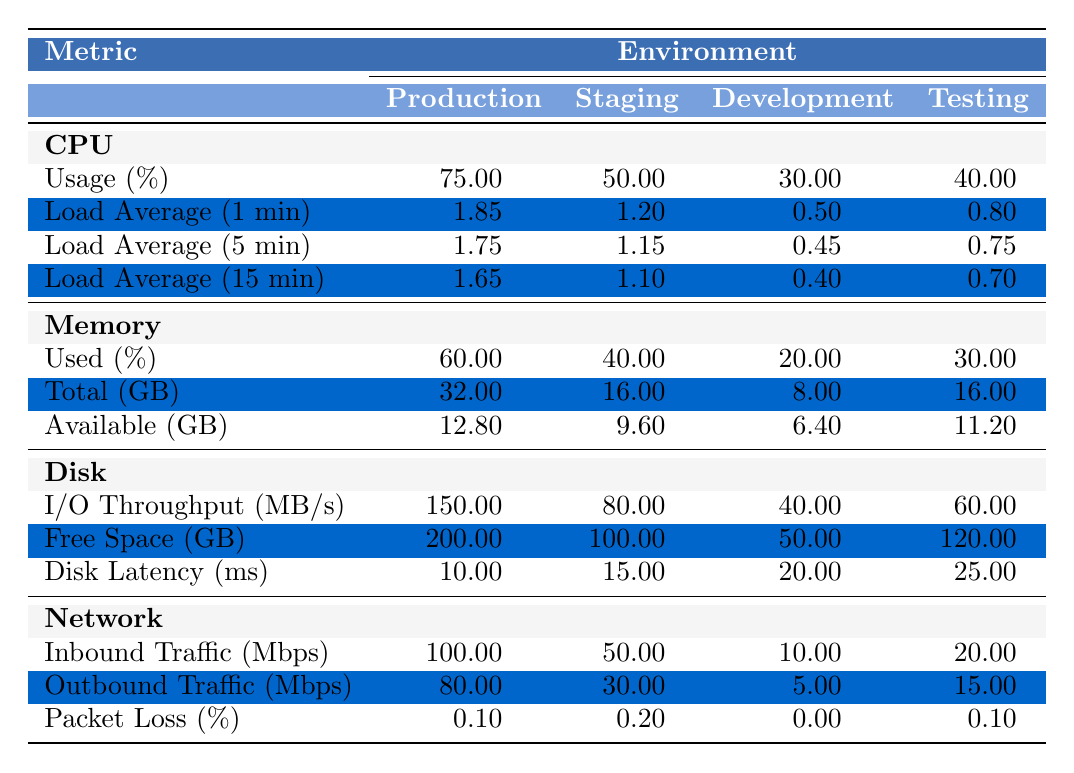What is the CPU usage percentage in the Production environment? The table indicates that the CPU usage percentage in the Production environment is clearly labeled under the CPU section. The value listed is 75.00%.
Answer: 75.00% Which environment has the highest disk I/O throughput? The I/O throughput values for each environment are listed in the Disk section. Production has the highest value at 150.00 MB/s, compared to other environments.
Answer: Production What is the difference in memory usage percentage between Staging and Development environments? The memory usage percentage for Staging is 40.00%, while Development is at 20.00%. The difference is calculated as 40.00% - 20.00% = 20.00%.
Answer: 20.00% Is there any packet loss in the Development environment? The packet loss percentage for Development is listed as 0.00%, indicating no packet loss in that environment.
Answer: No What is the average CPU load average (1 min) across all environments? The load averages for 1 minute across environments are: Production (1.85), Staging (1.20), Development (0.50), and Testing (0.80). The sum is 1.85 + 1.20 + 0.50 + 0.80 = 4.35; there are 4 environments, so the average is 4.35 / 4 = 1.0875.
Answer: 1.09 Which environment has the lowest available memory (GB)? From the table, the available memory for each environment is: Production (12.80), Staging (9.60), Development (6.40), and Testing (11.20). The lowest value is Development at 6.40 GB.
Answer: Development What is the total inbound traffic (Mbps) across Production and Staging environments? The inbound traffic for Production is 100.00 Mbps and for Staging is 50.00 Mbps. Adding these together gives 100.00 + 50.00 = 150.00 Mbps.
Answer: 150.00 Mbps What is the difference in free disk space (GB) between Production and Testing environments? The free disk space in Production is 200.00 GB, and in Testing, it is 120.00 GB. The difference is calculated as 200.00 - 120.00 = 80.00 GB.
Answer: 80.00 GB What is the highest network outbound traffic recorded? The outbound traffic values are: Production (80.00 Mbps), Staging (30.00 Mbps), Development (5.00 Mbps), and Testing (15.00 Mbps). The highest is Production at 80.00 Mbps.
Answer: Production Is the average disk latency (ms) across all environments above 15 ms? The disk latency values are: Production (10.00), Staging (15.00), Development (20.00), and Testing (25.00). The average is (10.00 + 15.00 + 20.00 + 25.00) / 4 = 17.50 ms, which is more than 15 ms.
Answer: Yes 